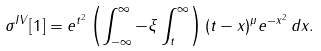<formula> <loc_0><loc_0><loc_500><loc_500>\sigma ^ { I V } [ 1 ] = e ^ { t ^ { 2 } } \left ( \int _ { - \infty } ^ { \infty } - \xi \int _ { t } ^ { \infty } \right ) ( t - x ) ^ { \mu } e ^ { - x ^ { 2 } } \, d x .</formula> 